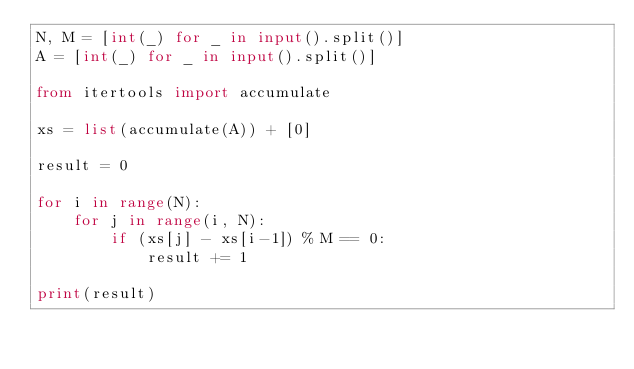<code> <loc_0><loc_0><loc_500><loc_500><_Python_>N, M = [int(_) for _ in input().split()]
A = [int(_) for _ in input().split()]

from itertools import accumulate

xs = list(accumulate(A)) + [0]

result = 0

for i in range(N):
    for j in range(i, N):
        if (xs[j] - xs[i-1]) % M == 0:
            result += 1

print(result)

</code> 